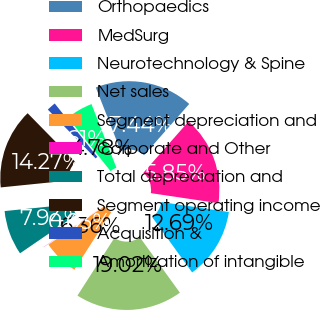Convert chart. <chart><loc_0><loc_0><loc_500><loc_500><pie_chart><fcel>Orthopaedics<fcel>MedSurg<fcel>Neurotechnology & Spine<fcel>Net sales<fcel>Segment depreciation and<fcel>Corporate and Other<fcel>Total depreciation and<fcel>Segment operating income<fcel>Acquisition &<fcel>Amortization of intangible<nl><fcel>17.44%<fcel>15.85%<fcel>12.69%<fcel>19.02%<fcel>6.36%<fcel>0.03%<fcel>7.94%<fcel>14.27%<fcel>1.61%<fcel>4.78%<nl></chart> 